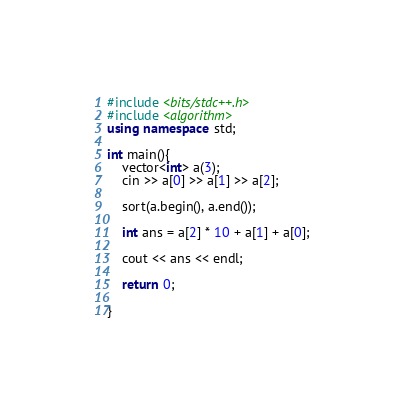<code> <loc_0><loc_0><loc_500><loc_500><_C++_>#include <bits/stdc++.h>
#include <algorithm>
using namespace std;

int main(){
    vector<int> a(3);
    cin >> a[0] >> a[1] >> a[2];

    sort(a.begin(), a.end());

    int ans = a[2] * 10 + a[1] + a[0];

    cout << ans << endl;

    return 0;

}
</code> 